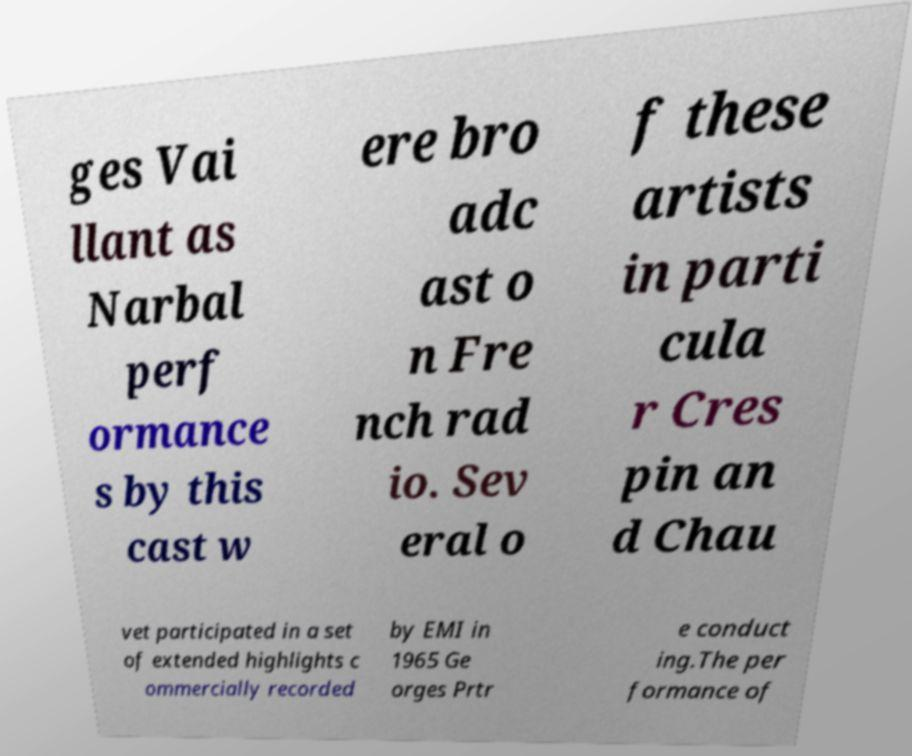For documentation purposes, I need the text within this image transcribed. Could you provide that? ges Vai llant as Narbal perf ormance s by this cast w ere bro adc ast o n Fre nch rad io. Sev eral o f these artists in parti cula r Cres pin an d Chau vet participated in a set of extended highlights c ommercially recorded by EMI in 1965 Ge orges Prtr e conduct ing.The per formance of 